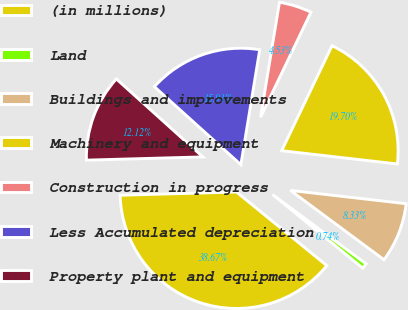Convert chart to OTSL. <chart><loc_0><loc_0><loc_500><loc_500><pie_chart><fcel>(in millions)<fcel>Land<fcel>Buildings and improvements<fcel>Machinery and equipment<fcel>Construction in progress<fcel>Less Accumulated depreciation<fcel>Property plant and equipment<nl><fcel>38.67%<fcel>0.74%<fcel>8.33%<fcel>19.7%<fcel>4.53%<fcel>15.91%<fcel>12.12%<nl></chart> 